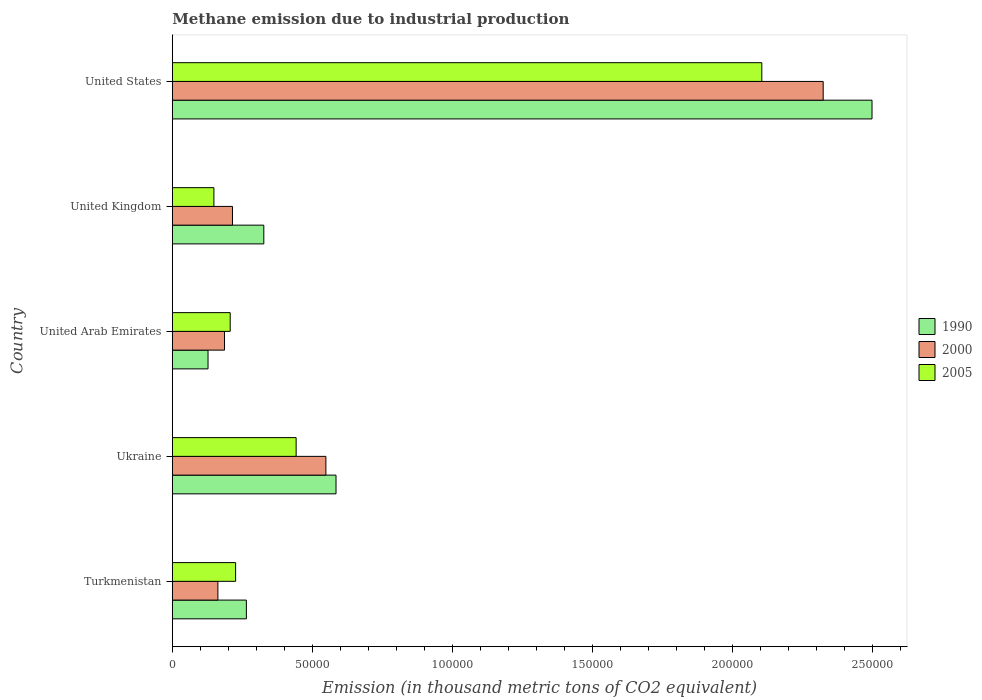How many different coloured bars are there?
Ensure brevity in your answer.  3. How many groups of bars are there?
Provide a short and direct response. 5. How many bars are there on the 2nd tick from the top?
Ensure brevity in your answer.  3. How many bars are there on the 1st tick from the bottom?
Your answer should be compact. 3. What is the label of the 3rd group of bars from the top?
Offer a terse response. United Arab Emirates. What is the amount of methane emitted in 2000 in Ukraine?
Keep it short and to the point. 5.48e+04. Across all countries, what is the maximum amount of methane emitted in 1990?
Your answer should be compact. 2.50e+05. Across all countries, what is the minimum amount of methane emitted in 1990?
Give a very brief answer. 1.27e+04. In which country was the amount of methane emitted in 2005 maximum?
Make the answer very short. United States. In which country was the amount of methane emitted in 1990 minimum?
Ensure brevity in your answer.  United Arab Emirates. What is the total amount of methane emitted in 2005 in the graph?
Keep it short and to the point. 3.13e+05. What is the difference between the amount of methane emitted in 2000 in United Arab Emirates and that in United Kingdom?
Ensure brevity in your answer.  -2844. What is the difference between the amount of methane emitted in 1990 in United States and the amount of methane emitted in 2000 in United Arab Emirates?
Offer a terse response. 2.31e+05. What is the average amount of methane emitted in 1990 per country?
Your answer should be compact. 7.60e+04. What is the difference between the amount of methane emitted in 1990 and amount of methane emitted in 2005 in United Kingdom?
Make the answer very short. 1.78e+04. What is the ratio of the amount of methane emitted in 1990 in Ukraine to that in United Arab Emirates?
Provide a succinct answer. 4.59. Is the amount of methane emitted in 1990 in Turkmenistan less than that in United Kingdom?
Provide a short and direct response. Yes. What is the difference between the highest and the second highest amount of methane emitted in 2005?
Keep it short and to the point. 1.66e+05. What is the difference between the highest and the lowest amount of methane emitted in 2005?
Keep it short and to the point. 1.96e+05. In how many countries, is the amount of methane emitted in 2000 greater than the average amount of methane emitted in 2000 taken over all countries?
Keep it short and to the point. 1. Is the sum of the amount of methane emitted in 2005 in Turkmenistan and United States greater than the maximum amount of methane emitted in 2000 across all countries?
Your response must be concise. Yes. What does the 2nd bar from the bottom in United Arab Emirates represents?
Provide a succinct answer. 2000. Is it the case that in every country, the sum of the amount of methane emitted in 2000 and amount of methane emitted in 1990 is greater than the amount of methane emitted in 2005?
Offer a very short reply. Yes. How many countries are there in the graph?
Make the answer very short. 5. How are the legend labels stacked?
Offer a terse response. Vertical. What is the title of the graph?
Keep it short and to the point. Methane emission due to industrial production. What is the label or title of the X-axis?
Make the answer very short. Emission (in thousand metric tons of CO2 equivalent). What is the Emission (in thousand metric tons of CO2 equivalent) in 1990 in Turkmenistan?
Provide a succinct answer. 2.64e+04. What is the Emission (in thousand metric tons of CO2 equivalent) in 2000 in Turkmenistan?
Your answer should be very brief. 1.63e+04. What is the Emission (in thousand metric tons of CO2 equivalent) in 2005 in Turkmenistan?
Offer a very short reply. 2.26e+04. What is the Emission (in thousand metric tons of CO2 equivalent) of 1990 in Ukraine?
Your answer should be compact. 5.84e+04. What is the Emission (in thousand metric tons of CO2 equivalent) in 2000 in Ukraine?
Keep it short and to the point. 5.48e+04. What is the Emission (in thousand metric tons of CO2 equivalent) in 2005 in Ukraine?
Your answer should be very brief. 4.42e+04. What is the Emission (in thousand metric tons of CO2 equivalent) of 1990 in United Arab Emirates?
Offer a terse response. 1.27e+04. What is the Emission (in thousand metric tons of CO2 equivalent) of 2000 in United Arab Emirates?
Keep it short and to the point. 1.86e+04. What is the Emission (in thousand metric tons of CO2 equivalent) of 2005 in United Arab Emirates?
Give a very brief answer. 2.07e+04. What is the Emission (in thousand metric tons of CO2 equivalent) of 1990 in United Kingdom?
Offer a very short reply. 3.27e+04. What is the Emission (in thousand metric tons of CO2 equivalent) in 2000 in United Kingdom?
Give a very brief answer. 2.15e+04. What is the Emission (in thousand metric tons of CO2 equivalent) of 2005 in United Kingdom?
Your answer should be compact. 1.48e+04. What is the Emission (in thousand metric tons of CO2 equivalent) in 1990 in United States?
Provide a short and direct response. 2.50e+05. What is the Emission (in thousand metric tons of CO2 equivalent) of 2000 in United States?
Offer a terse response. 2.32e+05. What is the Emission (in thousand metric tons of CO2 equivalent) of 2005 in United States?
Keep it short and to the point. 2.10e+05. Across all countries, what is the maximum Emission (in thousand metric tons of CO2 equivalent) in 1990?
Provide a short and direct response. 2.50e+05. Across all countries, what is the maximum Emission (in thousand metric tons of CO2 equivalent) in 2000?
Provide a succinct answer. 2.32e+05. Across all countries, what is the maximum Emission (in thousand metric tons of CO2 equivalent) of 2005?
Your answer should be very brief. 2.10e+05. Across all countries, what is the minimum Emission (in thousand metric tons of CO2 equivalent) in 1990?
Ensure brevity in your answer.  1.27e+04. Across all countries, what is the minimum Emission (in thousand metric tons of CO2 equivalent) of 2000?
Keep it short and to the point. 1.63e+04. Across all countries, what is the minimum Emission (in thousand metric tons of CO2 equivalent) in 2005?
Give a very brief answer. 1.48e+04. What is the total Emission (in thousand metric tons of CO2 equivalent) of 1990 in the graph?
Give a very brief answer. 3.80e+05. What is the total Emission (in thousand metric tons of CO2 equivalent) in 2000 in the graph?
Offer a very short reply. 3.44e+05. What is the total Emission (in thousand metric tons of CO2 equivalent) in 2005 in the graph?
Your response must be concise. 3.13e+05. What is the difference between the Emission (in thousand metric tons of CO2 equivalent) in 1990 in Turkmenistan and that in Ukraine?
Offer a terse response. -3.20e+04. What is the difference between the Emission (in thousand metric tons of CO2 equivalent) of 2000 in Turkmenistan and that in Ukraine?
Your response must be concise. -3.86e+04. What is the difference between the Emission (in thousand metric tons of CO2 equivalent) in 2005 in Turkmenistan and that in Ukraine?
Your answer should be compact. -2.16e+04. What is the difference between the Emission (in thousand metric tons of CO2 equivalent) in 1990 in Turkmenistan and that in United Arab Emirates?
Ensure brevity in your answer.  1.37e+04. What is the difference between the Emission (in thousand metric tons of CO2 equivalent) of 2000 in Turkmenistan and that in United Arab Emirates?
Make the answer very short. -2365.9. What is the difference between the Emission (in thousand metric tons of CO2 equivalent) in 2005 in Turkmenistan and that in United Arab Emirates?
Give a very brief answer. 1929.5. What is the difference between the Emission (in thousand metric tons of CO2 equivalent) of 1990 in Turkmenistan and that in United Kingdom?
Ensure brevity in your answer.  -6226. What is the difference between the Emission (in thousand metric tons of CO2 equivalent) in 2000 in Turkmenistan and that in United Kingdom?
Offer a very short reply. -5209.9. What is the difference between the Emission (in thousand metric tons of CO2 equivalent) in 2005 in Turkmenistan and that in United Kingdom?
Your answer should be very brief. 7746.1. What is the difference between the Emission (in thousand metric tons of CO2 equivalent) in 1990 in Turkmenistan and that in United States?
Your response must be concise. -2.23e+05. What is the difference between the Emission (in thousand metric tons of CO2 equivalent) in 2000 in Turkmenistan and that in United States?
Ensure brevity in your answer.  -2.16e+05. What is the difference between the Emission (in thousand metric tons of CO2 equivalent) in 2005 in Turkmenistan and that in United States?
Keep it short and to the point. -1.88e+05. What is the difference between the Emission (in thousand metric tons of CO2 equivalent) in 1990 in Ukraine and that in United Arab Emirates?
Offer a terse response. 4.57e+04. What is the difference between the Emission (in thousand metric tons of CO2 equivalent) in 2000 in Ukraine and that in United Arab Emirates?
Offer a terse response. 3.62e+04. What is the difference between the Emission (in thousand metric tons of CO2 equivalent) of 2005 in Ukraine and that in United Arab Emirates?
Offer a terse response. 2.35e+04. What is the difference between the Emission (in thousand metric tons of CO2 equivalent) in 1990 in Ukraine and that in United Kingdom?
Offer a very short reply. 2.58e+04. What is the difference between the Emission (in thousand metric tons of CO2 equivalent) in 2000 in Ukraine and that in United Kingdom?
Provide a short and direct response. 3.33e+04. What is the difference between the Emission (in thousand metric tons of CO2 equivalent) in 2005 in Ukraine and that in United Kingdom?
Provide a short and direct response. 2.94e+04. What is the difference between the Emission (in thousand metric tons of CO2 equivalent) in 1990 in Ukraine and that in United States?
Offer a terse response. -1.91e+05. What is the difference between the Emission (in thousand metric tons of CO2 equivalent) of 2000 in Ukraine and that in United States?
Ensure brevity in your answer.  -1.78e+05. What is the difference between the Emission (in thousand metric tons of CO2 equivalent) in 2005 in Ukraine and that in United States?
Ensure brevity in your answer.  -1.66e+05. What is the difference between the Emission (in thousand metric tons of CO2 equivalent) in 1990 in United Arab Emirates and that in United Kingdom?
Provide a short and direct response. -1.99e+04. What is the difference between the Emission (in thousand metric tons of CO2 equivalent) of 2000 in United Arab Emirates and that in United Kingdom?
Give a very brief answer. -2844. What is the difference between the Emission (in thousand metric tons of CO2 equivalent) of 2005 in United Arab Emirates and that in United Kingdom?
Your answer should be compact. 5816.6. What is the difference between the Emission (in thousand metric tons of CO2 equivalent) of 1990 in United Arab Emirates and that in United States?
Provide a short and direct response. -2.37e+05. What is the difference between the Emission (in thousand metric tons of CO2 equivalent) in 2000 in United Arab Emirates and that in United States?
Your answer should be compact. -2.14e+05. What is the difference between the Emission (in thousand metric tons of CO2 equivalent) of 2005 in United Arab Emirates and that in United States?
Provide a succinct answer. -1.90e+05. What is the difference between the Emission (in thousand metric tons of CO2 equivalent) of 1990 in United Kingdom and that in United States?
Give a very brief answer. -2.17e+05. What is the difference between the Emission (in thousand metric tons of CO2 equivalent) in 2000 in United Kingdom and that in United States?
Your answer should be very brief. -2.11e+05. What is the difference between the Emission (in thousand metric tons of CO2 equivalent) in 2005 in United Kingdom and that in United States?
Keep it short and to the point. -1.96e+05. What is the difference between the Emission (in thousand metric tons of CO2 equivalent) of 1990 in Turkmenistan and the Emission (in thousand metric tons of CO2 equivalent) of 2000 in Ukraine?
Your answer should be very brief. -2.84e+04. What is the difference between the Emission (in thousand metric tons of CO2 equivalent) of 1990 in Turkmenistan and the Emission (in thousand metric tons of CO2 equivalent) of 2005 in Ukraine?
Offer a very short reply. -1.78e+04. What is the difference between the Emission (in thousand metric tons of CO2 equivalent) of 2000 in Turkmenistan and the Emission (in thousand metric tons of CO2 equivalent) of 2005 in Ukraine?
Your answer should be very brief. -2.79e+04. What is the difference between the Emission (in thousand metric tons of CO2 equivalent) of 1990 in Turkmenistan and the Emission (in thousand metric tons of CO2 equivalent) of 2000 in United Arab Emirates?
Your answer should be compact. 7801.3. What is the difference between the Emission (in thousand metric tons of CO2 equivalent) of 1990 in Turkmenistan and the Emission (in thousand metric tons of CO2 equivalent) of 2005 in United Arab Emirates?
Keep it short and to the point. 5771.7. What is the difference between the Emission (in thousand metric tons of CO2 equivalent) of 2000 in Turkmenistan and the Emission (in thousand metric tons of CO2 equivalent) of 2005 in United Arab Emirates?
Keep it short and to the point. -4395.5. What is the difference between the Emission (in thousand metric tons of CO2 equivalent) of 1990 in Turkmenistan and the Emission (in thousand metric tons of CO2 equivalent) of 2000 in United Kingdom?
Make the answer very short. 4957.3. What is the difference between the Emission (in thousand metric tons of CO2 equivalent) of 1990 in Turkmenistan and the Emission (in thousand metric tons of CO2 equivalent) of 2005 in United Kingdom?
Make the answer very short. 1.16e+04. What is the difference between the Emission (in thousand metric tons of CO2 equivalent) of 2000 in Turkmenistan and the Emission (in thousand metric tons of CO2 equivalent) of 2005 in United Kingdom?
Give a very brief answer. 1421.1. What is the difference between the Emission (in thousand metric tons of CO2 equivalent) of 1990 in Turkmenistan and the Emission (in thousand metric tons of CO2 equivalent) of 2000 in United States?
Offer a terse response. -2.06e+05. What is the difference between the Emission (in thousand metric tons of CO2 equivalent) in 1990 in Turkmenistan and the Emission (in thousand metric tons of CO2 equivalent) in 2005 in United States?
Offer a terse response. -1.84e+05. What is the difference between the Emission (in thousand metric tons of CO2 equivalent) in 2000 in Turkmenistan and the Emission (in thousand metric tons of CO2 equivalent) in 2005 in United States?
Provide a succinct answer. -1.94e+05. What is the difference between the Emission (in thousand metric tons of CO2 equivalent) of 1990 in Ukraine and the Emission (in thousand metric tons of CO2 equivalent) of 2000 in United Arab Emirates?
Your answer should be very brief. 3.98e+04. What is the difference between the Emission (in thousand metric tons of CO2 equivalent) of 1990 in Ukraine and the Emission (in thousand metric tons of CO2 equivalent) of 2005 in United Arab Emirates?
Keep it short and to the point. 3.78e+04. What is the difference between the Emission (in thousand metric tons of CO2 equivalent) in 2000 in Ukraine and the Emission (in thousand metric tons of CO2 equivalent) in 2005 in United Arab Emirates?
Keep it short and to the point. 3.42e+04. What is the difference between the Emission (in thousand metric tons of CO2 equivalent) in 1990 in Ukraine and the Emission (in thousand metric tons of CO2 equivalent) in 2000 in United Kingdom?
Keep it short and to the point. 3.70e+04. What is the difference between the Emission (in thousand metric tons of CO2 equivalent) in 1990 in Ukraine and the Emission (in thousand metric tons of CO2 equivalent) in 2005 in United Kingdom?
Offer a very short reply. 4.36e+04. What is the difference between the Emission (in thousand metric tons of CO2 equivalent) in 2000 in Ukraine and the Emission (in thousand metric tons of CO2 equivalent) in 2005 in United Kingdom?
Ensure brevity in your answer.  4.00e+04. What is the difference between the Emission (in thousand metric tons of CO2 equivalent) of 1990 in Ukraine and the Emission (in thousand metric tons of CO2 equivalent) of 2000 in United States?
Your response must be concise. -1.74e+05. What is the difference between the Emission (in thousand metric tons of CO2 equivalent) of 1990 in Ukraine and the Emission (in thousand metric tons of CO2 equivalent) of 2005 in United States?
Your answer should be very brief. -1.52e+05. What is the difference between the Emission (in thousand metric tons of CO2 equivalent) in 2000 in Ukraine and the Emission (in thousand metric tons of CO2 equivalent) in 2005 in United States?
Provide a short and direct response. -1.56e+05. What is the difference between the Emission (in thousand metric tons of CO2 equivalent) in 1990 in United Arab Emirates and the Emission (in thousand metric tons of CO2 equivalent) in 2000 in United Kingdom?
Ensure brevity in your answer.  -8729.7. What is the difference between the Emission (in thousand metric tons of CO2 equivalent) of 1990 in United Arab Emirates and the Emission (in thousand metric tons of CO2 equivalent) of 2005 in United Kingdom?
Provide a short and direct response. -2098.7. What is the difference between the Emission (in thousand metric tons of CO2 equivalent) in 2000 in United Arab Emirates and the Emission (in thousand metric tons of CO2 equivalent) in 2005 in United Kingdom?
Give a very brief answer. 3787. What is the difference between the Emission (in thousand metric tons of CO2 equivalent) in 1990 in United Arab Emirates and the Emission (in thousand metric tons of CO2 equivalent) in 2000 in United States?
Provide a succinct answer. -2.20e+05. What is the difference between the Emission (in thousand metric tons of CO2 equivalent) in 1990 in United Arab Emirates and the Emission (in thousand metric tons of CO2 equivalent) in 2005 in United States?
Offer a terse response. -1.98e+05. What is the difference between the Emission (in thousand metric tons of CO2 equivalent) in 2000 in United Arab Emirates and the Emission (in thousand metric tons of CO2 equivalent) in 2005 in United States?
Offer a terse response. -1.92e+05. What is the difference between the Emission (in thousand metric tons of CO2 equivalent) in 1990 in United Kingdom and the Emission (in thousand metric tons of CO2 equivalent) in 2000 in United States?
Give a very brief answer. -2.00e+05. What is the difference between the Emission (in thousand metric tons of CO2 equivalent) in 1990 in United Kingdom and the Emission (in thousand metric tons of CO2 equivalent) in 2005 in United States?
Keep it short and to the point. -1.78e+05. What is the difference between the Emission (in thousand metric tons of CO2 equivalent) in 2000 in United Kingdom and the Emission (in thousand metric tons of CO2 equivalent) in 2005 in United States?
Your answer should be compact. -1.89e+05. What is the average Emission (in thousand metric tons of CO2 equivalent) of 1990 per country?
Give a very brief answer. 7.60e+04. What is the average Emission (in thousand metric tons of CO2 equivalent) in 2000 per country?
Give a very brief answer. 6.87e+04. What is the average Emission (in thousand metric tons of CO2 equivalent) in 2005 per country?
Keep it short and to the point. 6.25e+04. What is the difference between the Emission (in thousand metric tons of CO2 equivalent) of 1990 and Emission (in thousand metric tons of CO2 equivalent) of 2000 in Turkmenistan?
Ensure brevity in your answer.  1.02e+04. What is the difference between the Emission (in thousand metric tons of CO2 equivalent) in 1990 and Emission (in thousand metric tons of CO2 equivalent) in 2005 in Turkmenistan?
Provide a short and direct response. 3842.2. What is the difference between the Emission (in thousand metric tons of CO2 equivalent) of 2000 and Emission (in thousand metric tons of CO2 equivalent) of 2005 in Turkmenistan?
Keep it short and to the point. -6325. What is the difference between the Emission (in thousand metric tons of CO2 equivalent) of 1990 and Emission (in thousand metric tons of CO2 equivalent) of 2000 in Ukraine?
Your response must be concise. 3615.2. What is the difference between the Emission (in thousand metric tons of CO2 equivalent) of 1990 and Emission (in thousand metric tons of CO2 equivalent) of 2005 in Ukraine?
Ensure brevity in your answer.  1.42e+04. What is the difference between the Emission (in thousand metric tons of CO2 equivalent) of 2000 and Emission (in thousand metric tons of CO2 equivalent) of 2005 in Ukraine?
Your answer should be very brief. 1.06e+04. What is the difference between the Emission (in thousand metric tons of CO2 equivalent) of 1990 and Emission (in thousand metric tons of CO2 equivalent) of 2000 in United Arab Emirates?
Offer a terse response. -5885.7. What is the difference between the Emission (in thousand metric tons of CO2 equivalent) in 1990 and Emission (in thousand metric tons of CO2 equivalent) in 2005 in United Arab Emirates?
Offer a terse response. -7915.3. What is the difference between the Emission (in thousand metric tons of CO2 equivalent) of 2000 and Emission (in thousand metric tons of CO2 equivalent) of 2005 in United Arab Emirates?
Offer a terse response. -2029.6. What is the difference between the Emission (in thousand metric tons of CO2 equivalent) of 1990 and Emission (in thousand metric tons of CO2 equivalent) of 2000 in United Kingdom?
Your answer should be very brief. 1.12e+04. What is the difference between the Emission (in thousand metric tons of CO2 equivalent) of 1990 and Emission (in thousand metric tons of CO2 equivalent) of 2005 in United Kingdom?
Make the answer very short. 1.78e+04. What is the difference between the Emission (in thousand metric tons of CO2 equivalent) of 2000 and Emission (in thousand metric tons of CO2 equivalent) of 2005 in United Kingdom?
Your response must be concise. 6631. What is the difference between the Emission (in thousand metric tons of CO2 equivalent) of 1990 and Emission (in thousand metric tons of CO2 equivalent) of 2000 in United States?
Your answer should be very brief. 1.74e+04. What is the difference between the Emission (in thousand metric tons of CO2 equivalent) in 1990 and Emission (in thousand metric tons of CO2 equivalent) in 2005 in United States?
Your answer should be compact. 3.93e+04. What is the difference between the Emission (in thousand metric tons of CO2 equivalent) in 2000 and Emission (in thousand metric tons of CO2 equivalent) in 2005 in United States?
Your answer should be compact. 2.19e+04. What is the ratio of the Emission (in thousand metric tons of CO2 equivalent) in 1990 in Turkmenistan to that in Ukraine?
Give a very brief answer. 0.45. What is the ratio of the Emission (in thousand metric tons of CO2 equivalent) in 2000 in Turkmenistan to that in Ukraine?
Provide a succinct answer. 0.3. What is the ratio of the Emission (in thousand metric tons of CO2 equivalent) in 2005 in Turkmenistan to that in Ukraine?
Provide a short and direct response. 0.51. What is the ratio of the Emission (in thousand metric tons of CO2 equivalent) in 1990 in Turkmenistan to that in United Arab Emirates?
Your response must be concise. 2.07. What is the ratio of the Emission (in thousand metric tons of CO2 equivalent) of 2000 in Turkmenistan to that in United Arab Emirates?
Your answer should be very brief. 0.87. What is the ratio of the Emission (in thousand metric tons of CO2 equivalent) of 2005 in Turkmenistan to that in United Arab Emirates?
Provide a succinct answer. 1.09. What is the ratio of the Emission (in thousand metric tons of CO2 equivalent) of 1990 in Turkmenistan to that in United Kingdom?
Your answer should be compact. 0.81. What is the ratio of the Emission (in thousand metric tons of CO2 equivalent) of 2000 in Turkmenistan to that in United Kingdom?
Keep it short and to the point. 0.76. What is the ratio of the Emission (in thousand metric tons of CO2 equivalent) of 2005 in Turkmenistan to that in United Kingdom?
Keep it short and to the point. 1.52. What is the ratio of the Emission (in thousand metric tons of CO2 equivalent) of 1990 in Turkmenistan to that in United States?
Your answer should be compact. 0.11. What is the ratio of the Emission (in thousand metric tons of CO2 equivalent) of 2000 in Turkmenistan to that in United States?
Give a very brief answer. 0.07. What is the ratio of the Emission (in thousand metric tons of CO2 equivalent) in 2005 in Turkmenistan to that in United States?
Your response must be concise. 0.11. What is the ratio of the Emission (in thousand metric tons of CO2 equivalent) in 1990 in Ukraine to that in United Arab Emirates?
Provide a short and direct response. 4.59. What is the ratio of the Emission (in thousand metric tons of CO2 equivalent) of 2000 in Ukraine to that in United Arab Emirates?
Your answer should be very brief. 2.94. What is the ratio of the Emission (in thousand metric tons of CO2 equivalent) of 2005 in Ukraine to that in United Arab Emirates?
Offer a very short reply. 2.14. What is the ratio of the Emission (in thousand metric tons of CO2 equivalent) of 1990 in Ukraine to that in United Kingdom?
Provide a short and direct response. 1.79. What is the ratio of the Emission (in thousand metric tons of CO2 equivalent) of 2000 in Ukraine to that in United Kingdom?
Keep it short and to the point. 2.55. What is the ratio of the Emission (in thousand metric tons of CO2 equivalent) of 2005 in Ukraine to that in United Kingdom?
Offer a terse response. 2.98. What is the ratio of the Emission (in thousand metric tons of CO2 equivalent) of 1990 in Ukraine to that in United States?
Your answer should be very brief. 0.23. What is the ratio of the Emission (in thousand metric tons of CO2 equivalent) in 2000 in Ukraine to that in United States?
Keep it short and to the point. 0.24. What is the ratio of the Emission (in thousand metric tons of CO2 equivalent) of 2005 in Ukraine to that in United States?
Give a very brief answer. 0.21. What is the ratio of the Emission (in thousand metric tons of CO2 equivalent) of 1990 in United Arab Emirates to that in United Kingdom?
Offer a terse response. 0.39. What is the ratio of the Emission (in thousand metric tons of CO2 equivalent) in 2000 in United Arab Emirates to that in United Kingdom?
Provide a succinct answer. 0.87. What is the ratio of the Emission (in thousand metric tons of CO2 equivalent) of 2005 in United Arab Emirates to that in United Kingdom?
Your answer should be compact. 1.39. What is the ratio of the Emission (in thousand metric tons of CO2 equivalent) of 1990 in United Arab Emirates to that in United States?
Provide a short and direct response. 0.05. What is the ratio of the Emission (in thousand metric tons of CO2 equivalent) in 2000 in United Arab Emirates to that in United States?
Provide a short and direct response. 0.08. What is the ratio of the Emission (in thousand metric tons of CO2 equivalent) of 2005 in United Arab Emirates to that in United States?
Provide a succinct answer. 0.1. What is the ratio of the Emission (in thousand metric tons of CO2 equivalent) in 1990 in United Kingdom to that in United States?
Offer a very short reply. 0.13. What is the ratio of the Emission (in thousand metric tons of CO2 equivalent) in 2000 in United Kingdom to that in United States?
Make the answer very short. 0.09. What is the ratio of the Emission (in thousand metric tons of CO2 equivalent) of 2005 in United Kingdom to that in United States?
Keep it short and to the point. 0.07. What is the difference between the highest and the second highest Emission (in thousand metric tons of CO2 equivalent) of 1990?
Your answer should be very brief. 1.91e+05. What is the difference between the highest and the second highest Emission (in thousand metric tons of CO2 equivalent) in 2000?
Provide a succinct answer. 1.78e+05. What is the difference between the highest and the second highest Emission (in thousand metric tons of CO2 equivalent) of 2005?
Your answer should be very brief. 1.66e+05. What is the difference between the highest and the lowest Emission (in thousand metric tons of CO2 equivalent) of 1990?
Provide a succinct answer. 2.37e+05. What is the difference between the highest and the lowest Emission (in thousand metric tons of CO2 equivalent) of 2000?
Provide a succinct answer. 2.16e+05. What is the difference between the highest and the lowest Emission (in thousand metric tons of CO2 equivalent) in 2005?
Provide a short and direct response. 1.96e+05. 